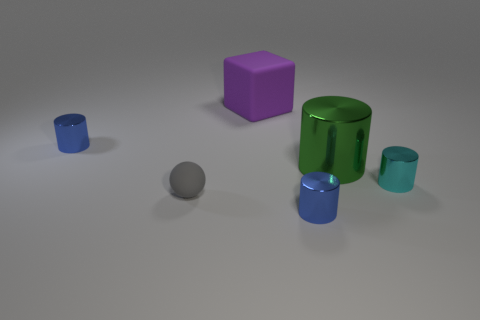Subtract all green cylinders. How many cylinders are left? 3 Add 2 tiny cylinders. How many objects exist? 8 Subtract all brown cylinders. Subtract all blue cubes. How many cylinders are left? 4 Subtract all blocks. How many objects are left? 5 Add 6 gray rubber objects. How many gray rubber objects are left? 7 Add 3 large purple rubber objects. How many large purple rubber objects exist? 4 Subtract 1 blue cylinders. How many objects are left? 5 Subtract all large red metal objects. Subtract all tiny cylinders. How many objects are left? 3 